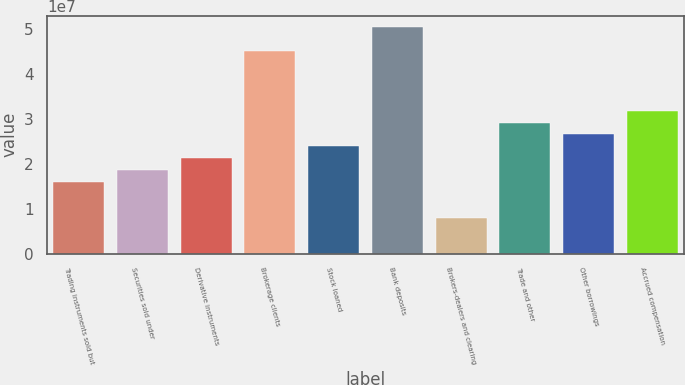Convert chart to OTSL. <chart><loc_0><loc_0><loc_500><loc_500><bar_chart><fcel>Trading instruments sold but<fcel>Securities sold under<fcel>Derivative instruments<fcel>Brokerage clients<fcel>Stock loaned<fcel>Bank deposits<fcel>Brokers-dealers and clearing<fcel>Trade and other<fcel>Other borrowings<fcel>Accrued compensation<nl><fcel>1.58884e+07<fcel>1.85362e+07<fcel>2.1184e+07<fcel>4.50144e+07<fcel>2.38319e+07<fcel>5.03101e+07<fcel>7.94495e+06<fcel>2.91275e+07<fcel>2.64797e+07<fcel>3.17753e+07<nl></chart> 